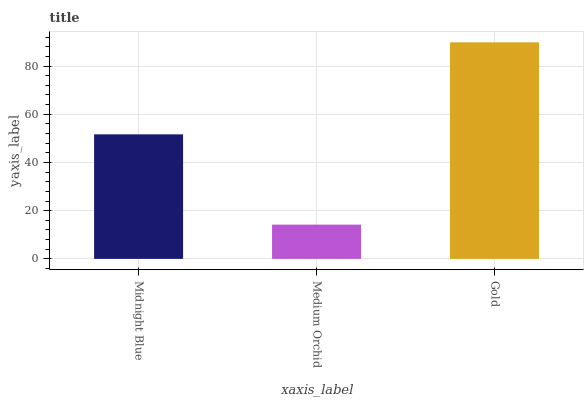Is Medium Orchid the minimum?
Answer yes or no. Yes. Is Gold the maximum?
Answer yes or no. Yes. Is Gold the minimum?
Answer yes or no. No. Is Medium Orchid the maximum?
Answer yes or no. No. Is Gold greater than Medium Orchid?
Answer yes or no. Yes. Is Medium Orchid less than Gold?
Answer yes or no. Yes. Is Medium Orchid greater than Gold?
Answer yes or no. No. Is Gold less than Medium Orchid?
Answer yes or no. No. Is Midnight Blue the high median?
Answer yes or no. Yes. Is Midnight Blue the low median?
Answer yes or no. Yes. Is Medium Orchid the high median?
Answer yes or no. No. Is Gold the low median?
Answer yes or no. No. 